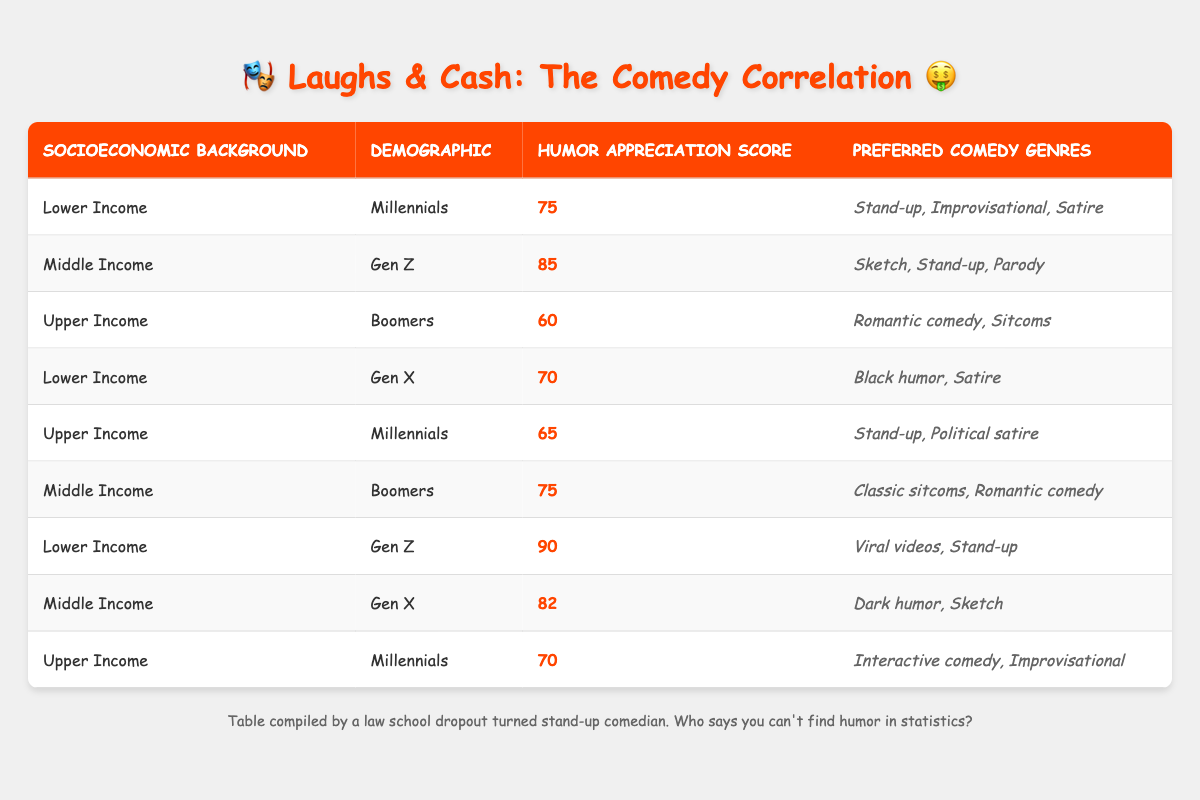What is the humor appreciation score for Lower Income Millennials? From the table, Lower Income Millennials have a humor appreciation score listed at 75.
Answer: 75 Which demographic has the highest humor appreciation score? By examining each score in the table, the highest score is found for Lower Income Gen Z, which is 90.
Answer: 90 Is the humor appreciation score for Upper Income Millennials higher than for Upper Income Boomers? The score for Upper Income Millennials is 70, while Upper Income Boomers have a score of 60. Since 70 is greater than 60, the statement is true.
Answer: Yes What is the average humor appreciation score for Middle Income demographics? The scores for Middle Income demographics are 85 (Gen Z), 75 (Boomers), and 82 (Gen X). When we sum these scores (85 + 75 + 82 = 242) and divide by 3, the average is 242/3 = 80.67.
Answer: 80.67 Which comedy genre is preferred by Lower Income Gen Z? The table indicates that Lower Income Gen Z prefers "Viral videos" and "Stand-up" as their comedy genres.
Answer: Viral videos, Stand-up Which socioeconomic group has the lowest average humor appreciation score? The scores for the lower income group are 75 (Millennials), 90 (Gen Z), and 70 (Gen X), averaging (75 + 90 + 70)/3 = 78.33. The upper income group's average (70 + 60 + 65)/3 = 65 is lower than any other group. Thus, Upper Income has the lowest average score.
Answer: Upper Income Do Middle Income Gen Z and Lower Income Gen Z prefer the same comedy genres? Lower Income Gen Z prefers "Viral videos" and "Stand-up," while Middle Income Gen Z prefers "Sketch," "Stand-up," and "Parody." They do not share the same genres, so the answer is false.
Answer: No What is the total number of preferred comedy genres listed for Upper Income Millennials? The table shows that Upper Income Millennials prefer two genres: "Interactive comedy" and "Improvisational." Thus, the total count is 2.
Answer: 2 Which socioeconomic background has more diversity in preferred comedy genres? By reviewing, Middle Income demographics show three genres for Gen Z (Sketch, Stand-up, Parody), and Gen X (Dark Humor, Sketch), while Lower Income has consistent genres that vary less. Thus, Middle Income has more diversity in genres.
Answer: Middle Income 